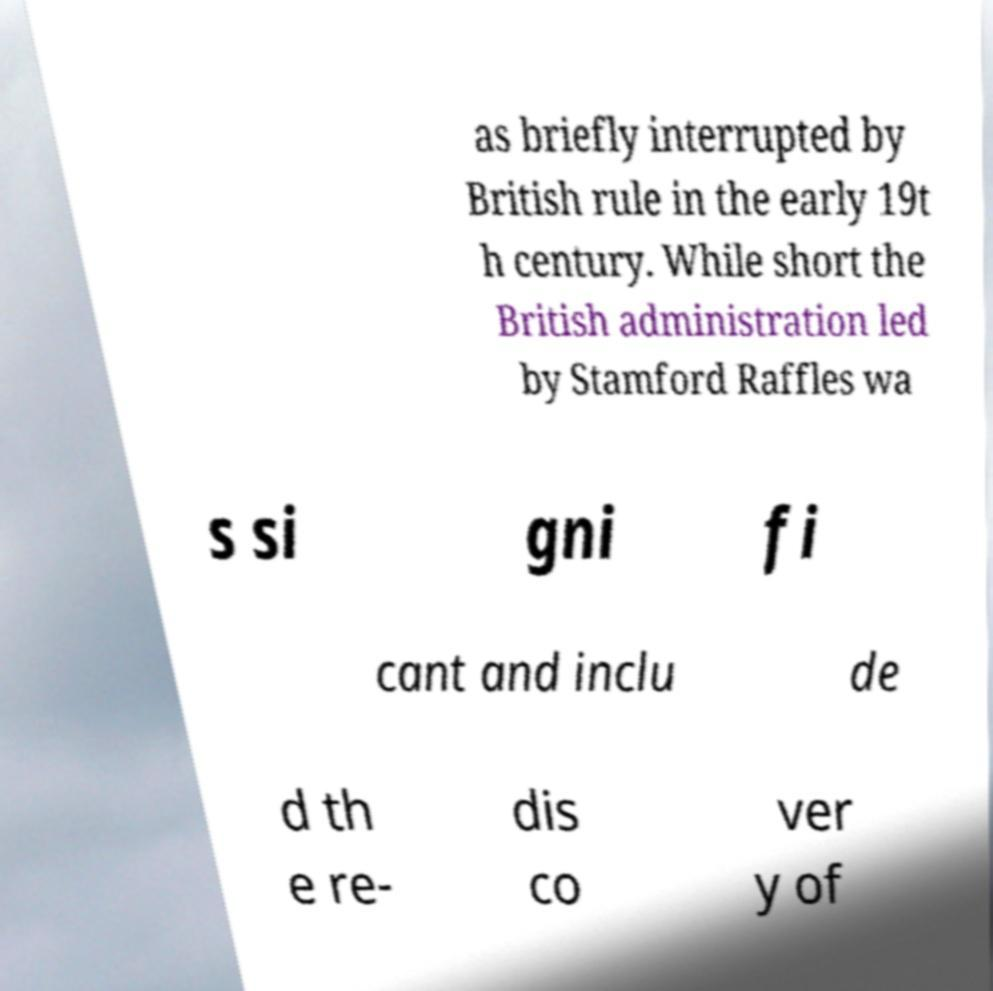Please identify and transcribe the text found in this image. as briefly interrupted by British rule in the early 19t h century. While short the British administration led by Stamford Raffles wa s si gni fi cant and inclu de d th e re- dis co ver y of 